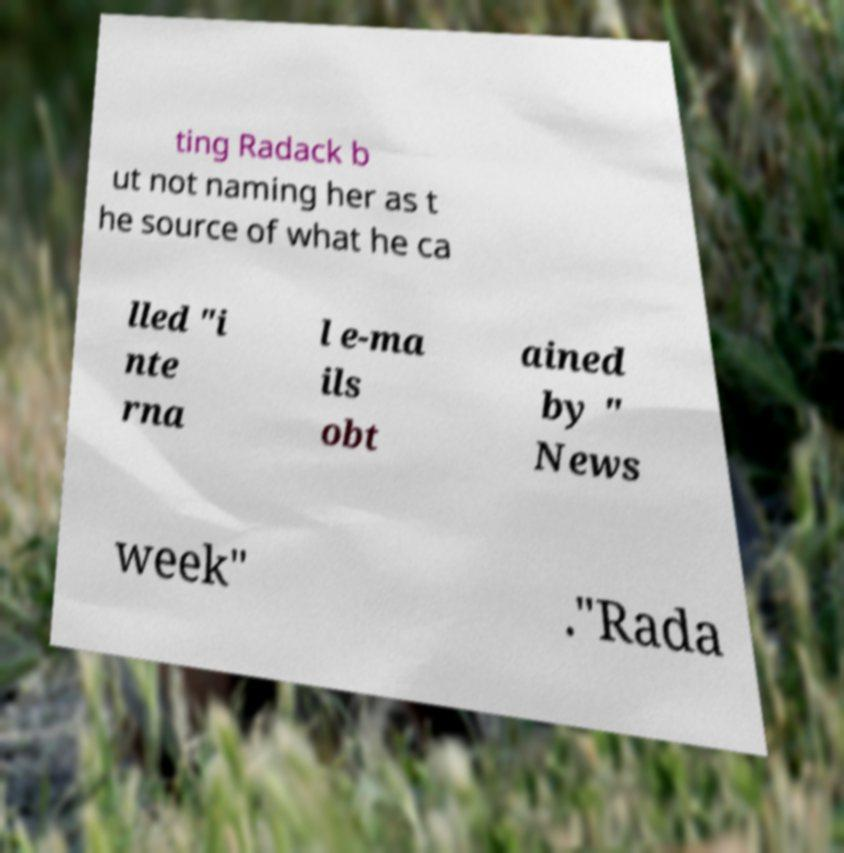Could you extract and type out the text from this image? ting Radack b ut not naming her as t he source of what he ca lled "i nte rna l e-ma ils obt ained by " News week" ."Rada 